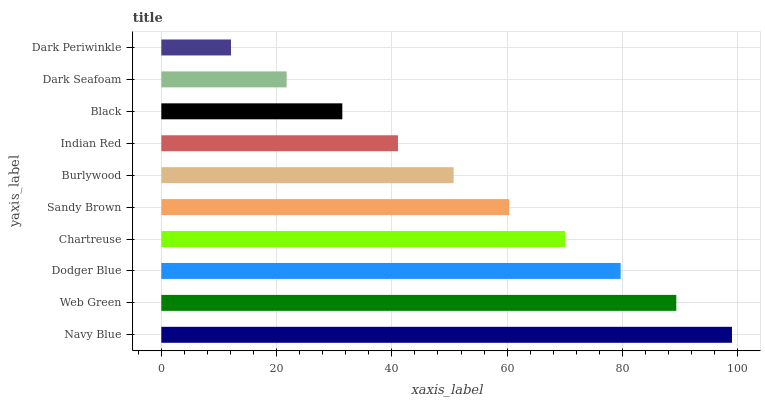Is Dark Periwinkle the minimum?
Answer yes or no. Yes. Is Navy Blue the maximum?
Answer yes or no. Yes. Is Web Green the minimum?
Answer yes or no. No. Is Web Green the maximum?
Answer yes or no. No. Is Navy Blue greater than Web Green?
Answer yes or no. Yes. Is Web Green less than Navy Blue?
Answer yes or no. Yes. Is Web Green greater than Navy Blue?
Answer yes or no. No. Is Navy Blue less than Web Green?
Answer yes or no. No. Is Sandy Brown the high median?
Answer yes or no. Yes. Is Burlywood the low median?
Answer yes or no. Yes. Is Black the high median?
Answer yes or no. No. Is Web Green the low median?
Answer yes or no. No. 